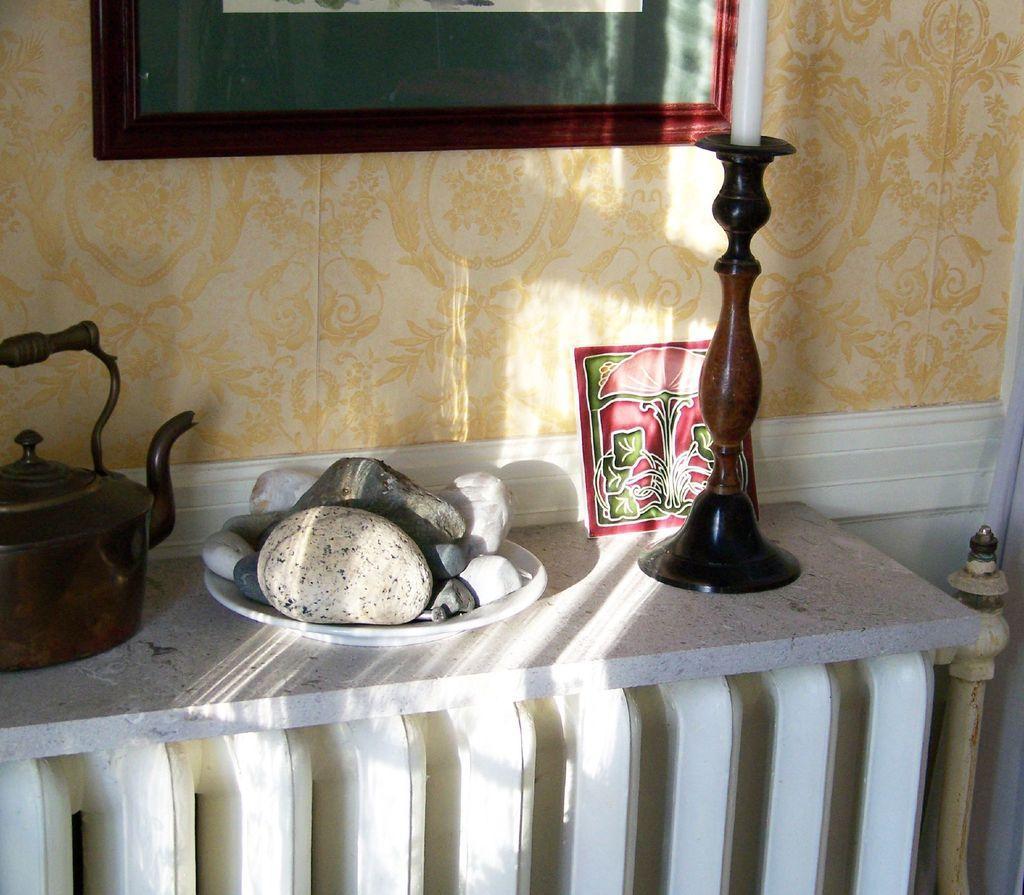Please provide a concise description of this image. In this image we can see a kettle, pebbles in a plate, candle stand, and a frame on the platform. In the background we can see wall and a frame which is truncated. 